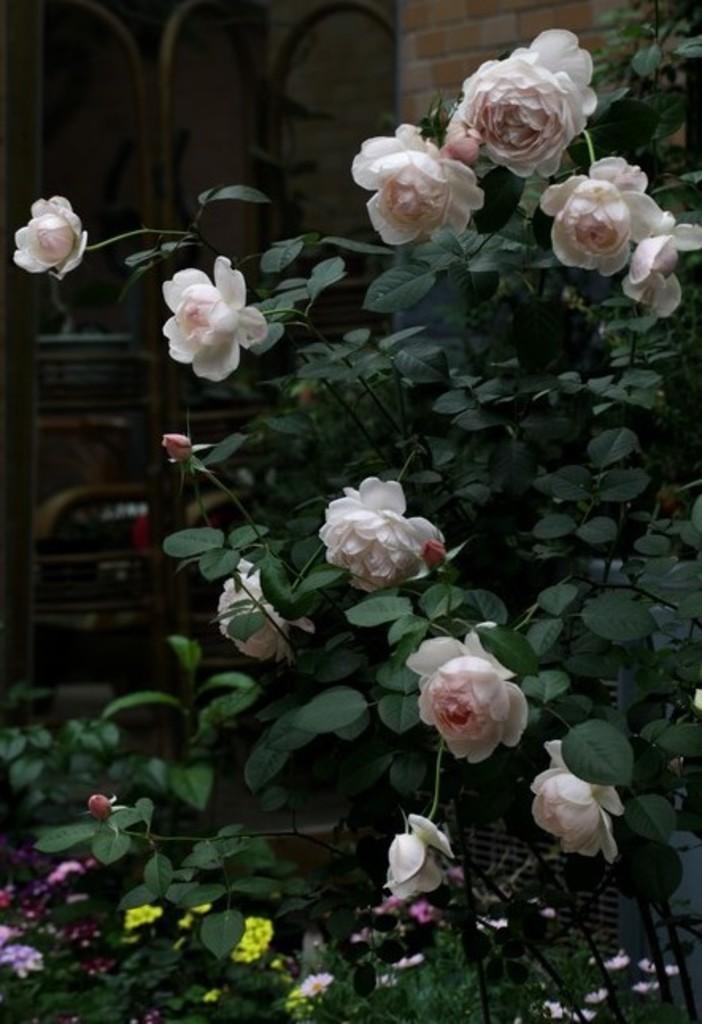Can you describe this image briefly? In this picture there is a pink color rose flower plant. Behind there is brick wall and a metal frame grill. 